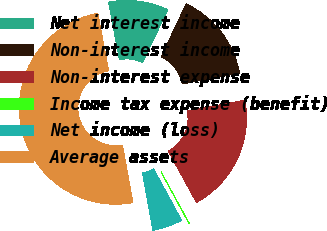<chart> <loc_0><loc_0><loc_500><loc_500><pie_chart><fcel>Net interest income<fcel>Non-interest income<fcel>Non-interest expense<fcel>Income tax expense (benefit)<fcel>Net income (loss)<fcel>Average assets<nl><fcel>10.02%<fcel>15.01%<fcel>19.99%<fcel>0.06%<fcel>5.04%<fcel>49.88%<nl></chart> 